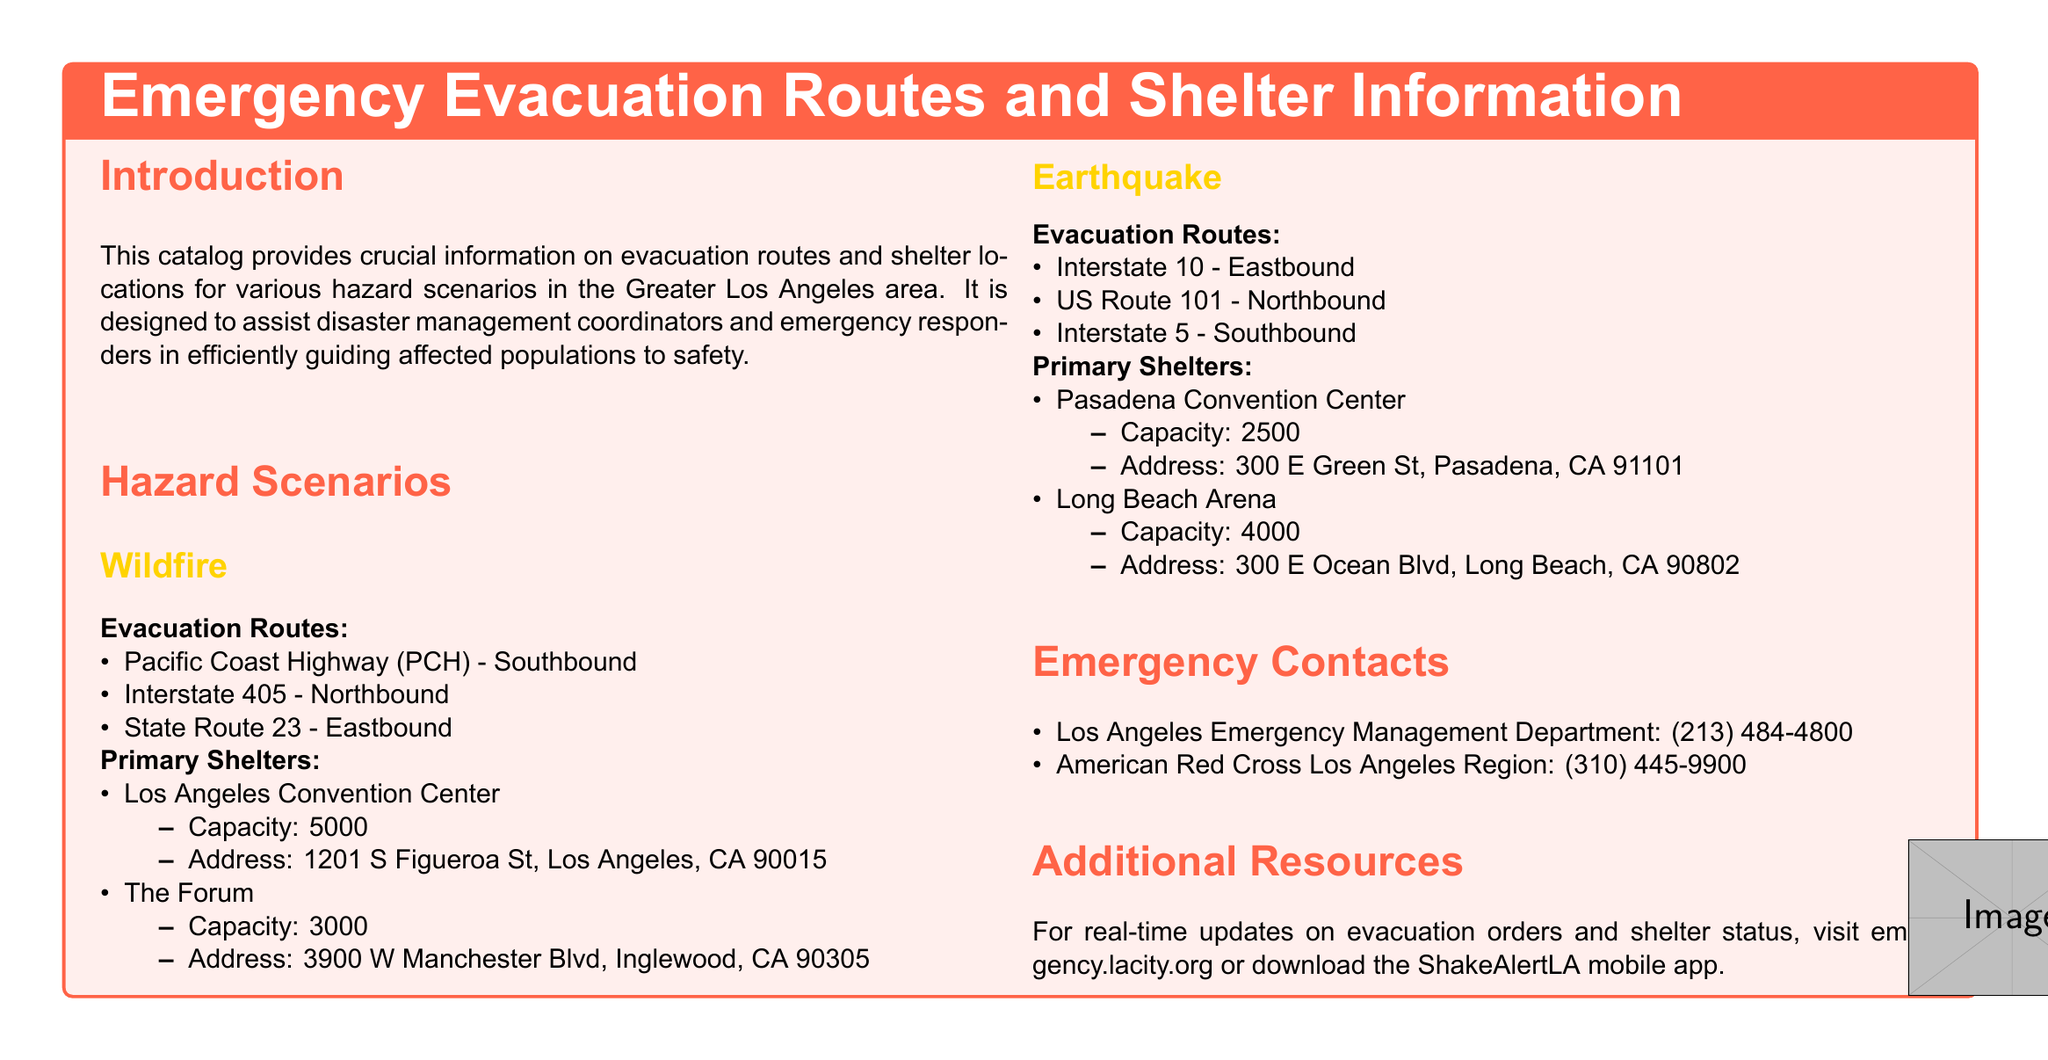What are the evacuation routes for wildfires? The evacuation routes for wildfires are specific roads mentioned in the section, which are critical for escape.
Answer: Pacific Coast Highway (PCH) - Southbound, Interstate 405 - Northbound, State Route 23 - Eastbound What is the capacity of Los Angeles Convention Center as a primary shelter? The capacity figure is included in the detailed list of primary shelters under the wildfire scenario.
Answer: 5000 Which hazard scenario includes Pasadena Convention Center? This refers to the section detailing primary shelters for specific hazard scenarios, thus linking the shelter to its relevant scenario.
Answer: Earthquake How many primary shelters are listed under the wildfire scenario? The document provides a specific count of shelters under the wildfire section, indicating the number available for displaced populations.
Answer: 2 What is the emergency contact number for the Los Angeles Emergency Management Department? The document contains this number in the emergency contacts section, highlighting crucial support for disaster response.
Answer: (213) 484-4800 How many evacuation routes are provided for the earthquake scenario? The number of evacuation routes is specified in the section pertaining to the earthquake hazard, indicating pathways for safety.
Answer: 3 What is the address of The Forum? The address listing is detailed alongside the capacity for The Forum under primary shelters, identifying its location for evacuees.
Answer: 3900 W Manchester Blvd, Inglewood, CA 90305 Which shelter has the highest capacity listed in the document? This question requires a comparison of capacities listed in the shelters section, identifying the largest facility for sheltering displaced individuals.
Answer: Los Angeles Convention Center What is the website for real-time updates on evacuation orders? The document provides this resource in the additional resources section, facilitating immediate access to crucial information.
Answer: emergency.lacity.org 